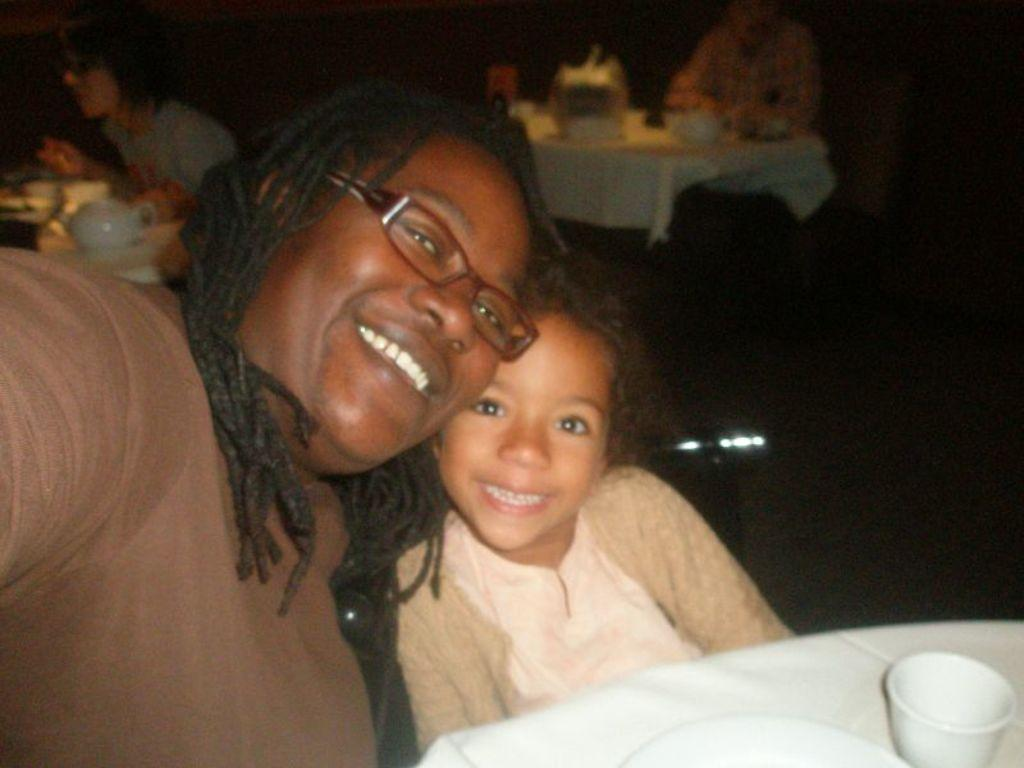What are the people in the image doing? The people in the image are sitting. What can be seen in the hands of the people or on the tables? There are cups visible in the image. What else is present on the tables in the image? There are objects on the tables in the image. What color is the background of the image? The background of the image is black. What type of tank is visible in the image? There is no tank present in the image. How much growth can be seen on the sack in the image? There is no sack present in the image. 